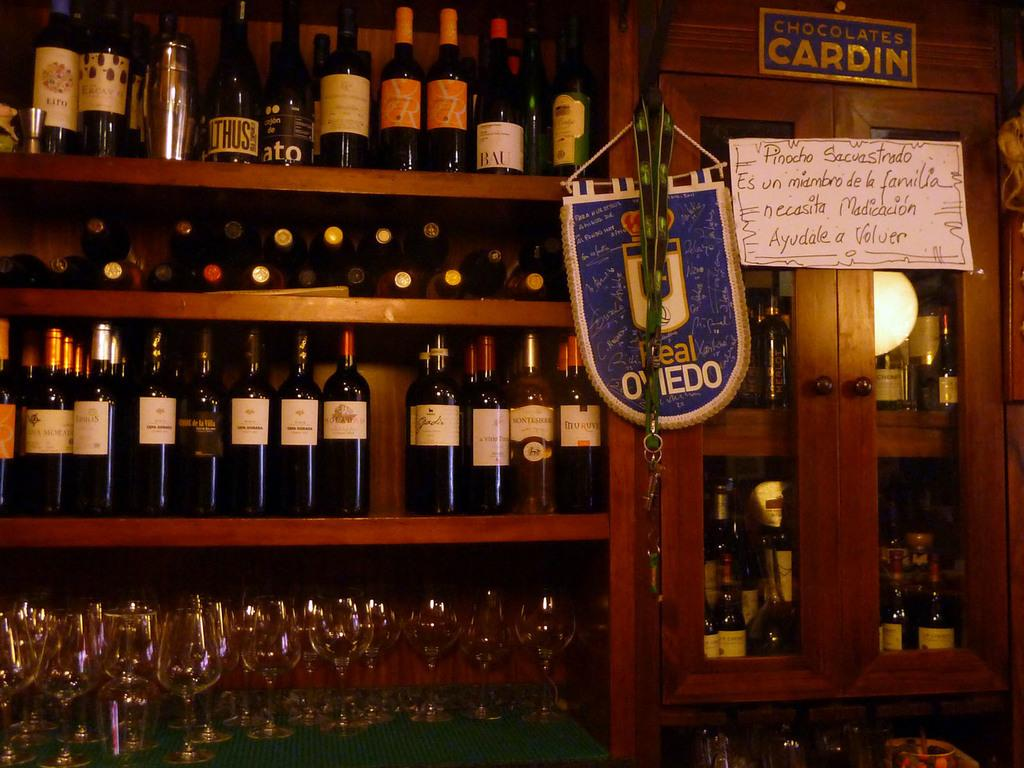What is the main object in the image? There is a wine rack in the image. What is stored in the wine rack? The wine rack contains bottles and glasses. Is there any additional feature attached to the wine rack? Yes, there is a board attached to the wine rack. How many fingers can be seen holding the wine glasses in the image? There are no fingers or hands visible in the image; it only shows the wine rack, bottles, glasses, and the board. 